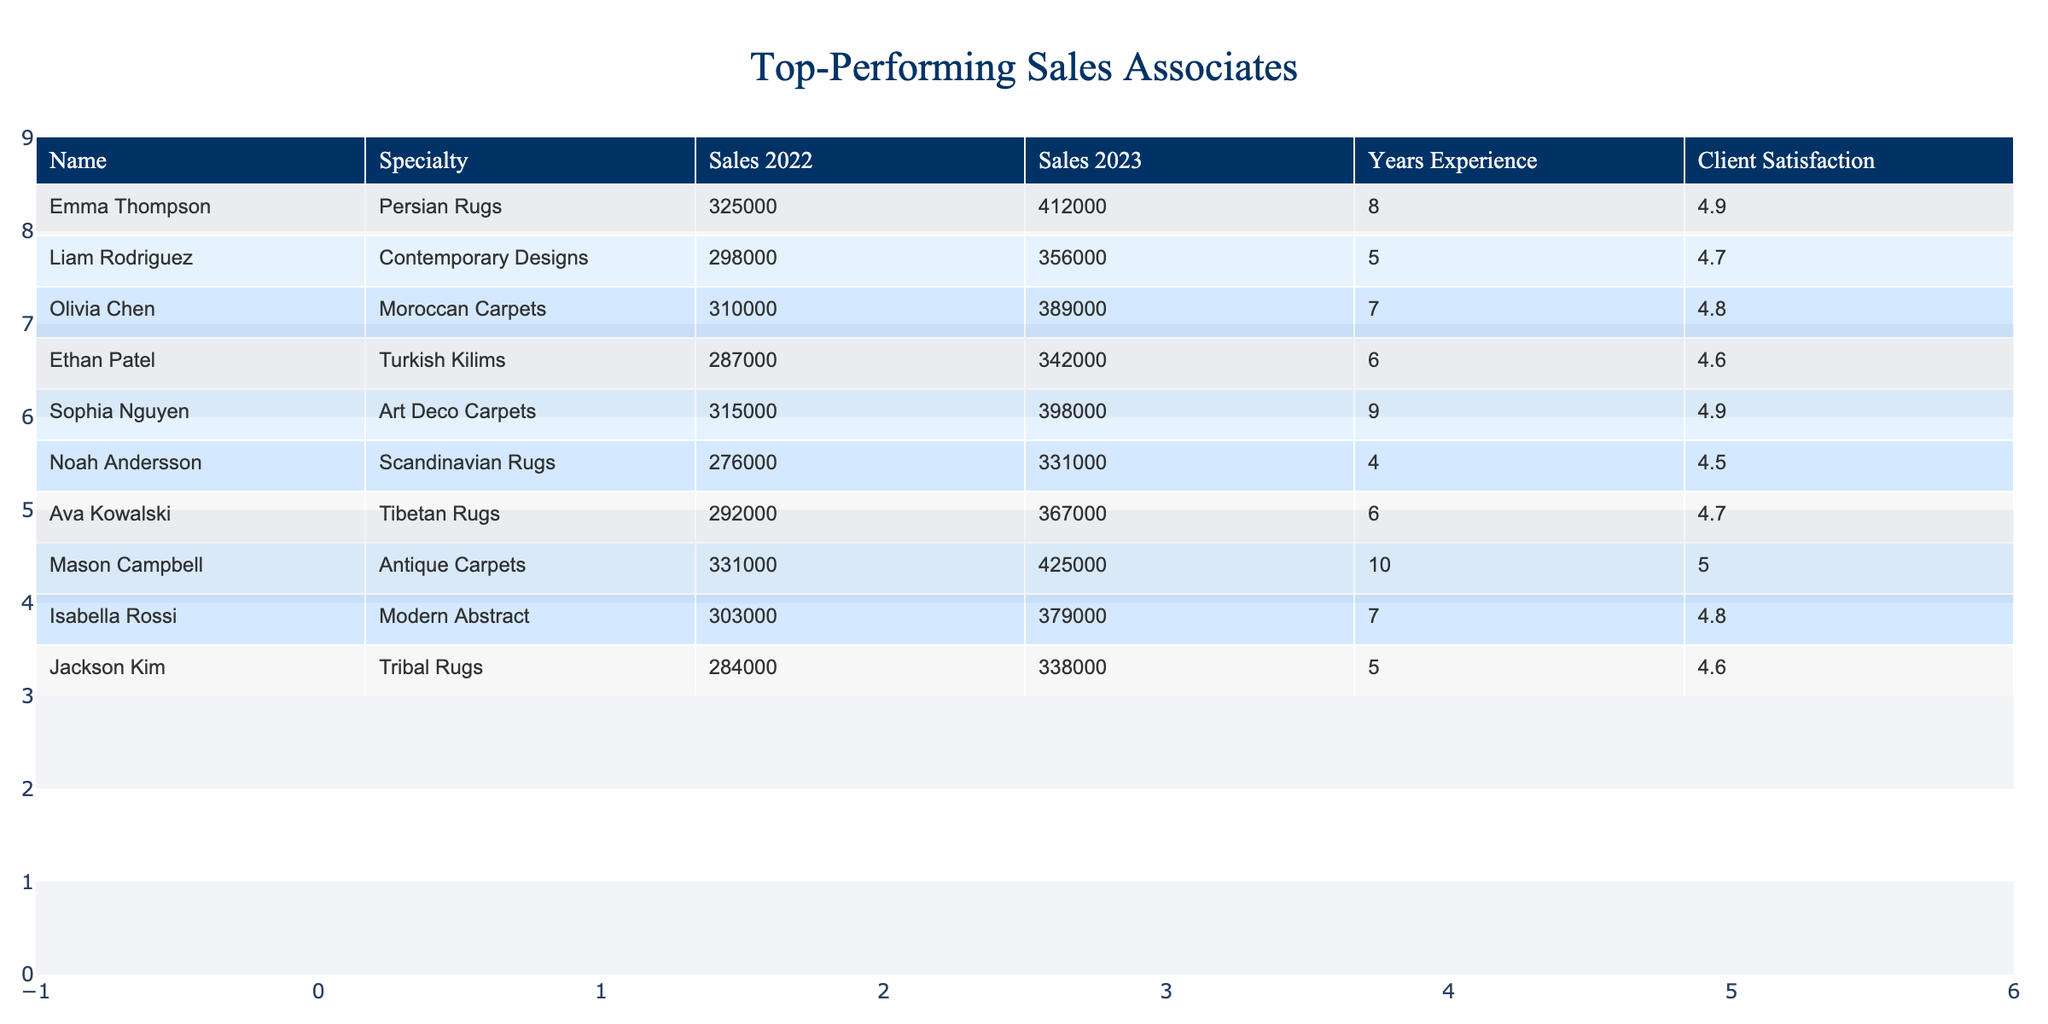What is the highest sales amount in 2023? By examining the 'Sales 2023' column in the table, I can see that Mason Campbell has the highest sales amount at 425,000.
Answer: 425000 Which sales associate specializes in Antique Carpets? The table shows that Mason Campbell is the sales associate who specializes in Antique Carpets.
Answer: Mason Campbell What is the average client satisfaction rating of the associates listed? I sum the client satisfaction ratings (4.9 + 4.7 + 4.8 + 4.6 + 4.9 + 4.5 + 4.7 + 5.0 + 4.8 + 4.6 = 48.5) and divide by the number of associates (10), resulting in an average of 48.5/10 = 4.85.
Answer: 4.85 Did Emma Thompson's sales increase or decrease from 2022 to 2023? By comparing the 'Sales 2022' (325,000) to 'Sales 2023' (412,000) for Emma Thompson, I see that her sales increased.
Answer: Increased Which associate has the most years of experience and what is their specialty? Upon reviewing the 'Years Experience' column, Mason Campbell has the most experience at 10 years, specializing in Antique Carpets.
Answer: Mason Campbell, Antique Carpets What is the difference in sales between Liam Rodriguez's 2022 and 2023 figures? I find the sales for Liam Rodriguez: 2022 is 298,000 and 2023 is 356,000. The difference is 356,000 - 298,000 = 58,000.
Answer: 58000 What percentage increase in sales did Olivia Chen achieve from 2022 to 2023? For Olivia Chen, the sales in 2022 were 310,000 and in 2023 were 389,000. The increase is 389,000 - 310,000 = 79,000. The percentage increase is (79,000 / 310,000) * 100 ≈ 25.48%.
Answer: 25.48% Which specialty has the lowest sales in 2023 and what is that amount? By reviewing the 'Sales 2023' column, I see that Noah Andersson with Scandinavian Rugs has the lowest sales amount at 331,000.
Answer: 331000 How many sales associates have a client satisfaction rating above 4.8? Looking at the 'Client Satisfaction' column, I find 6 associates with ratings above 4.8: Emma Thompson, Sophia Nguyen, and Mason Campbell.
Answer: 6 Is there a sales associate with the same specialty but different sales figures in 2023? By examining the table, I find both Olivia Chen and Ava Kowalski specialize in unique carpet styles but with different figures in sales for 2023. Olivia’s is 389,000 and Ava's is 367,000. So, yes, there are differences.
Answer: Yes What is the total sales amount of all associates combined in 2023? I add the sales figures from the 'Sales 2023' column (412000 + 356000 + 389000 + 342000 + 398000 + 331000 + 367000 + 425000 + 379000 + 338000 =  3,840,000).
Answer: 3840000 